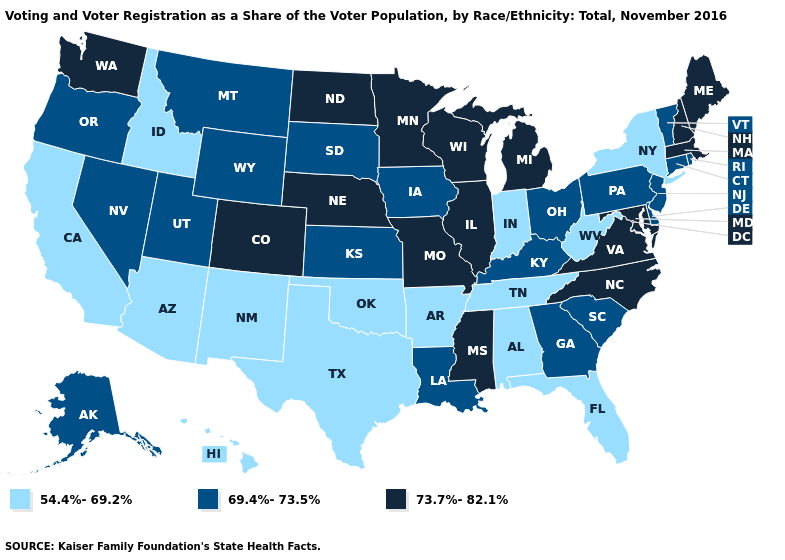Does South Dakota have the lowest value in the USA?
Be succinct. No. Name the states that have a value in the range 54.4%-69.2%?
Keep it brief. Alabama, Arizona, Arkansas, California, Florida, Hawaii, Idaho, Indiana, New Mexico, New York, Oklahoma, Tennessee, Texas, West Virginia. Does Idaho have a higher value than North Carolina?
Concise answer only. No. What is the value of Ohio?
Give a very brief answer. 69.4%-73.5%. What is the value of Texas?
Give a very brief answer. 54.4%-69.2%. Is the legend a continuous bar?
Keep it brief. No. What is the value of Colorado?
Answer briefly. 73.7%-82.1%. Does North Carolina have the same value as Arizona?
Quick response, please. No. Name the states that have a value in the range 54.4%-69.2%?
Write a very short answer. Alabama, Arizona, Arkansas, California, Florida, Hawaii, Idaho, Indiana, New Mexico, New York, Oklahoma, Tennessee, Texas, West Virginia. What is the value of Delaware?
Answer briefly. 69.4%-73.5%. What is the value of Washington?
Short answer required. 73.7%-82.1%. What is the value of New Jersey?
Short answer required. 69.4%-73.5%. How many symbols are there in the legend?
Concise answer only. 3. Name the states that have a value in the range 54.4%-69.2%?
Answer briefly. Alabama, Arizona, Arkansas, California, Florida, Hawaii, Idaho, Indiana, New Mexico, New York, Oklahoma, Tennessee, Texas, West Virginia. 